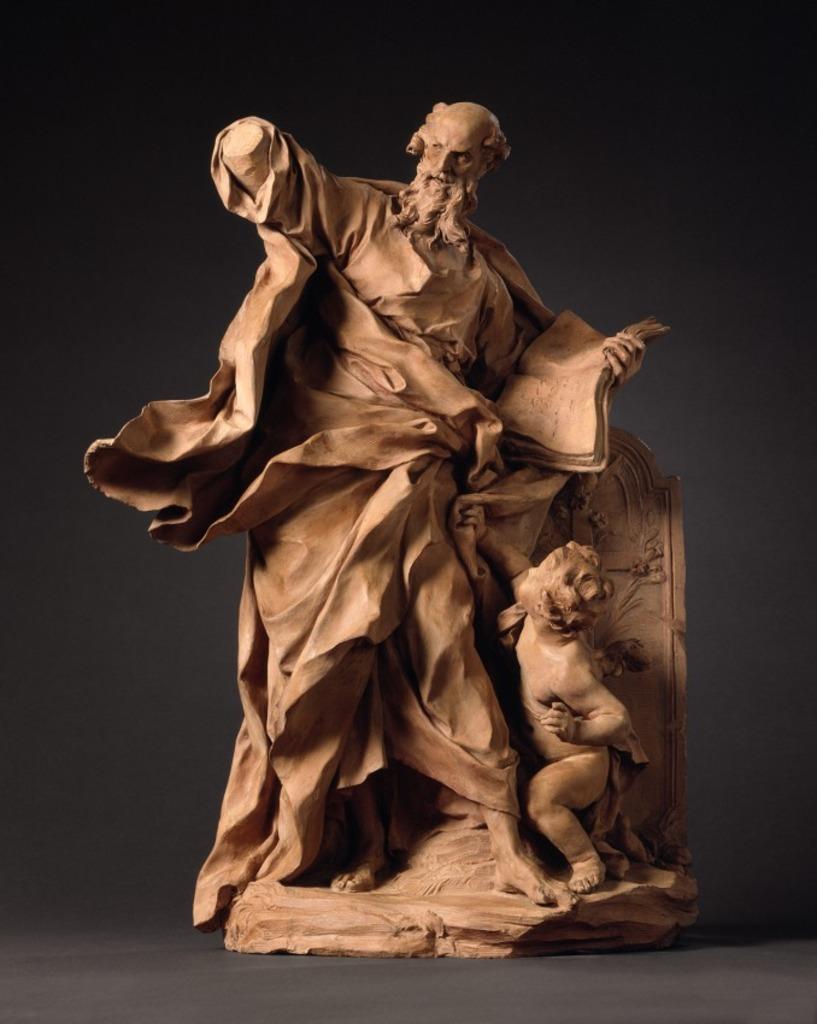Describe this image in one or two sentences. In this image there is a sculpture. 